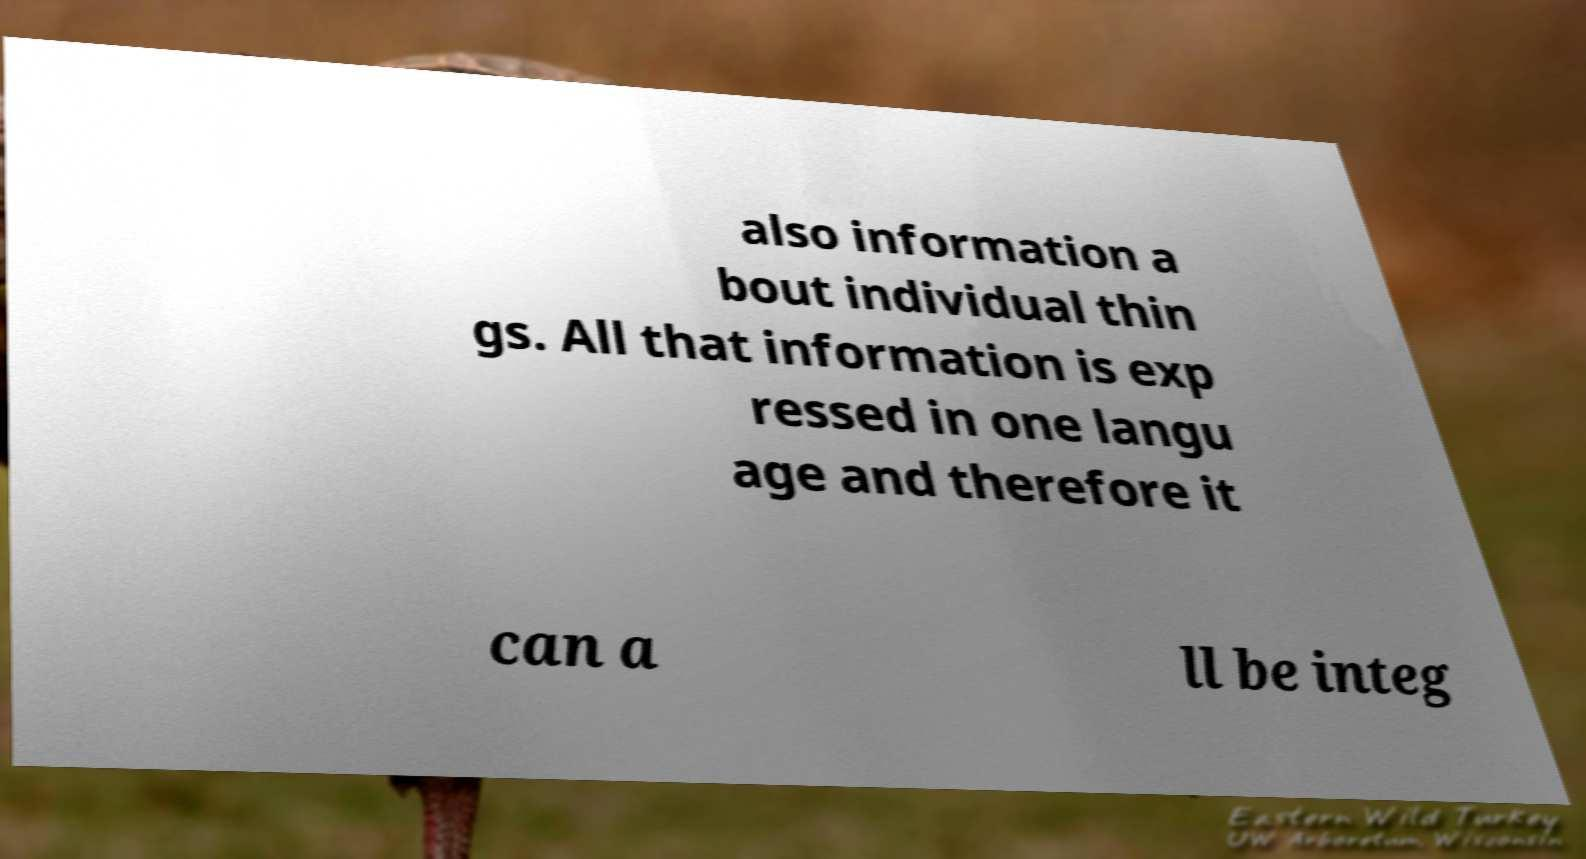Can you read and provide the text displayed in the image?This photo seems to have some interesting text. Can you extract and type it out for me? also information a bout individual thin gs. All that information is exp ressed in one langu age and therefore it can a ll be integ 